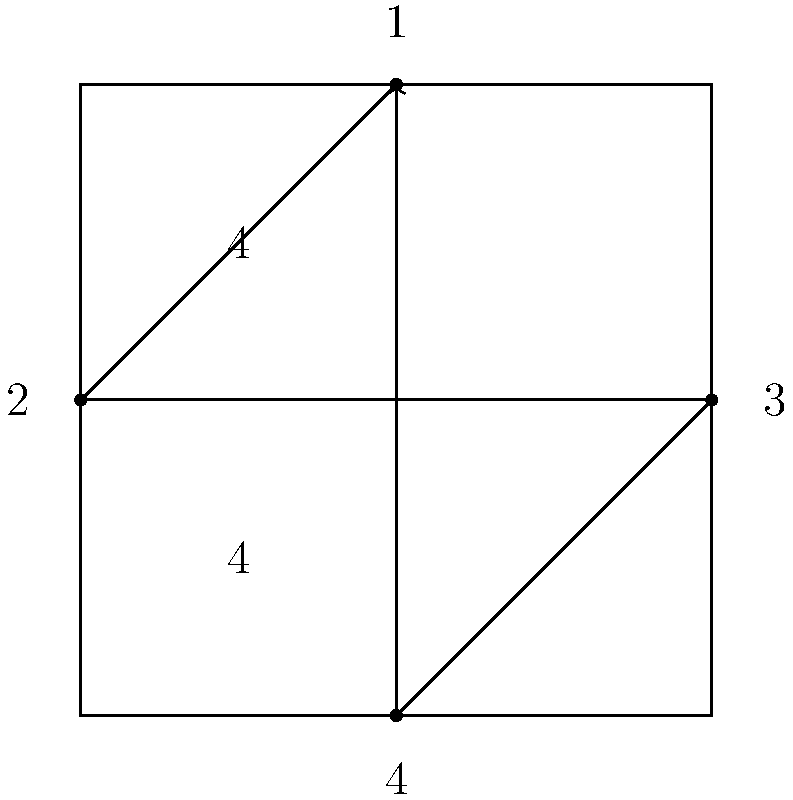Identify the time signature and describe the corresponding conducting pattern shown in the diagram. To answer this question, let's analyze the diagram step-by-step:

1. Time Signature:
   - The diagram shows two numbers stacked vertically on the left side.
   - The top number is 4, and the bottom number is also 4.
   - This represents a 4/4 time signature, also known as common time.

2. Conducting Pattern:
   - The diagram shows a diamond-shaped pattern with arrows indicating the direction of movement.
   - There are four numbered points on the pattern, corresponding to the four beats in 4/4 time.

3. Beat Sequence:
   - Beat 1: Starts at the top of the diamond (downbeat)
   - Beat 2: Moves to the left
   - Beat 3: Moves to the right
   - Beat 4: Moves to the bottom of the diamond

4. Pattern Description:
   - The conductor's hand moves in a down-left-right-up pattern.
   - This creates a clear visual representation of the four beats in each measure.

5. Importance:
   - This pattern helps musicians follow the conductor's gestures and maintain proper timing.
   - It provides a consistent visual cue for each beat in the measure.

In conclusion, the diagram represents a 4/4 time signature with a four-beat conducting pattern in a diamond shape.
Answer: 4/4 time signature; diamond-shaped pattern (down-left-right-up) 